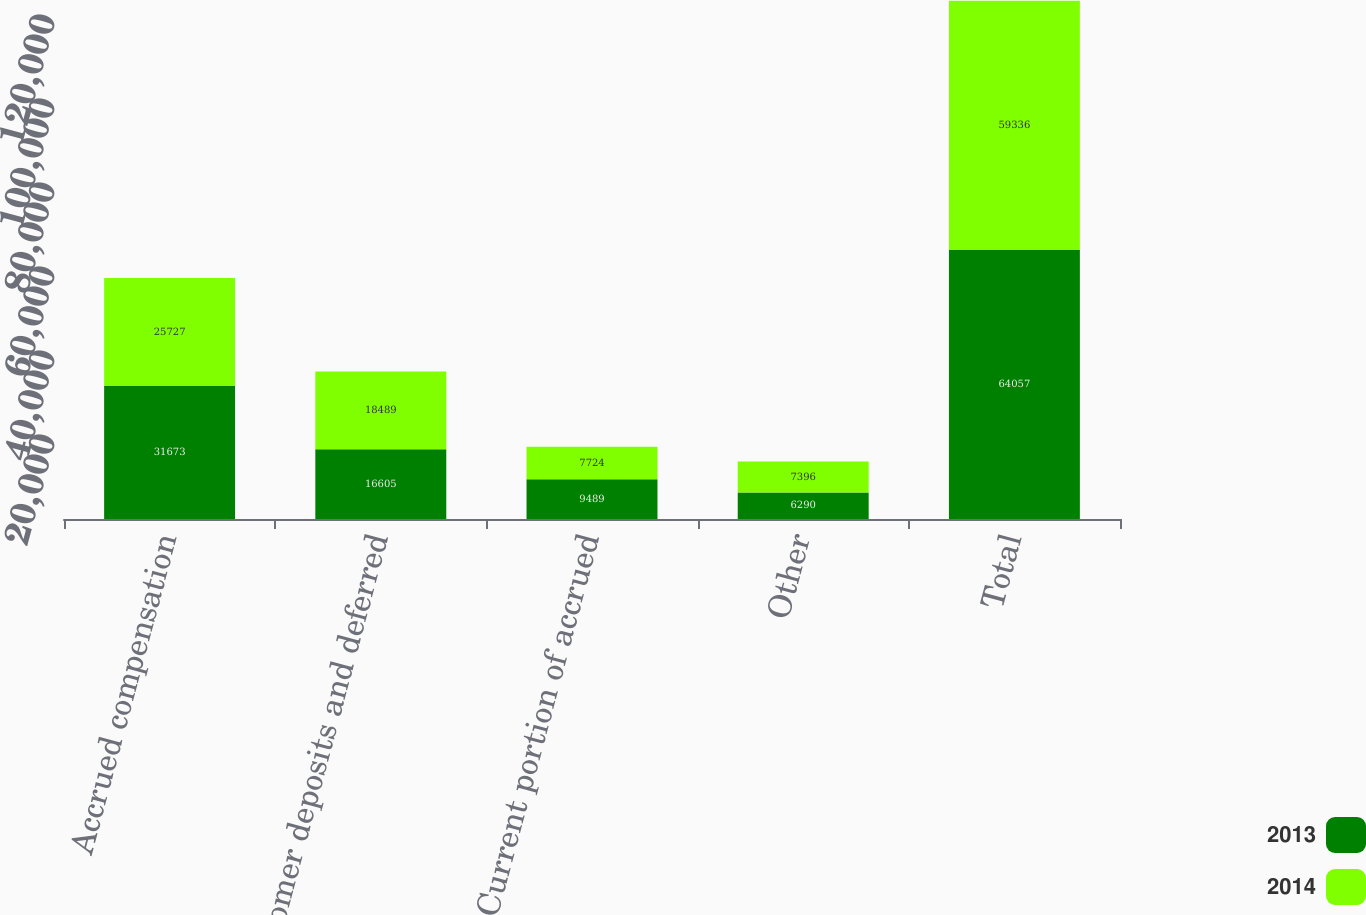<chart> <loc_0><loc_0><loc_500><loc_500><stacked_bar_chart><ecel><fcel>Accrued compensation<fcel>Customer deposits and deferred<fcel>Current portion of accrued<fcel>Other<fcel>Total<nl><fcel>2013<fcel>31673<fcel>16605<fcel>9489<fcel>6290<fcel>64057<nl><fcel>2014<fcel>25727<fcel>18489<fcel>7724<fcel>7396<fcel>59336<nl></chart> 